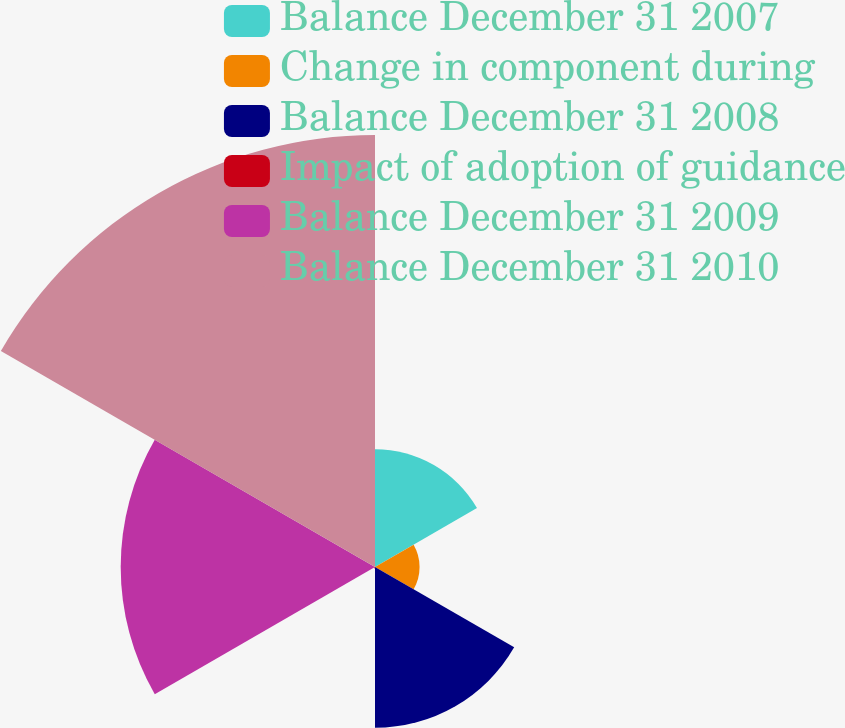Convert chart to OTSL. <chart><loc_0><loc_0><loc_500><loc_500><pie_chart><fcel>Balance December 31 2007<fcel>Change in component during<fcel>Balance December 31 2008<fcel>Impact of adoption of guidance<fcel>Balance December 31 2009<fcel>Balance December 31 2010<nl><fcel>11.65%<fcel>4.41%<fcel>15.9%<fcel>0.15%<fcel>25.16%<fcel>42.74%<nl></chart> 